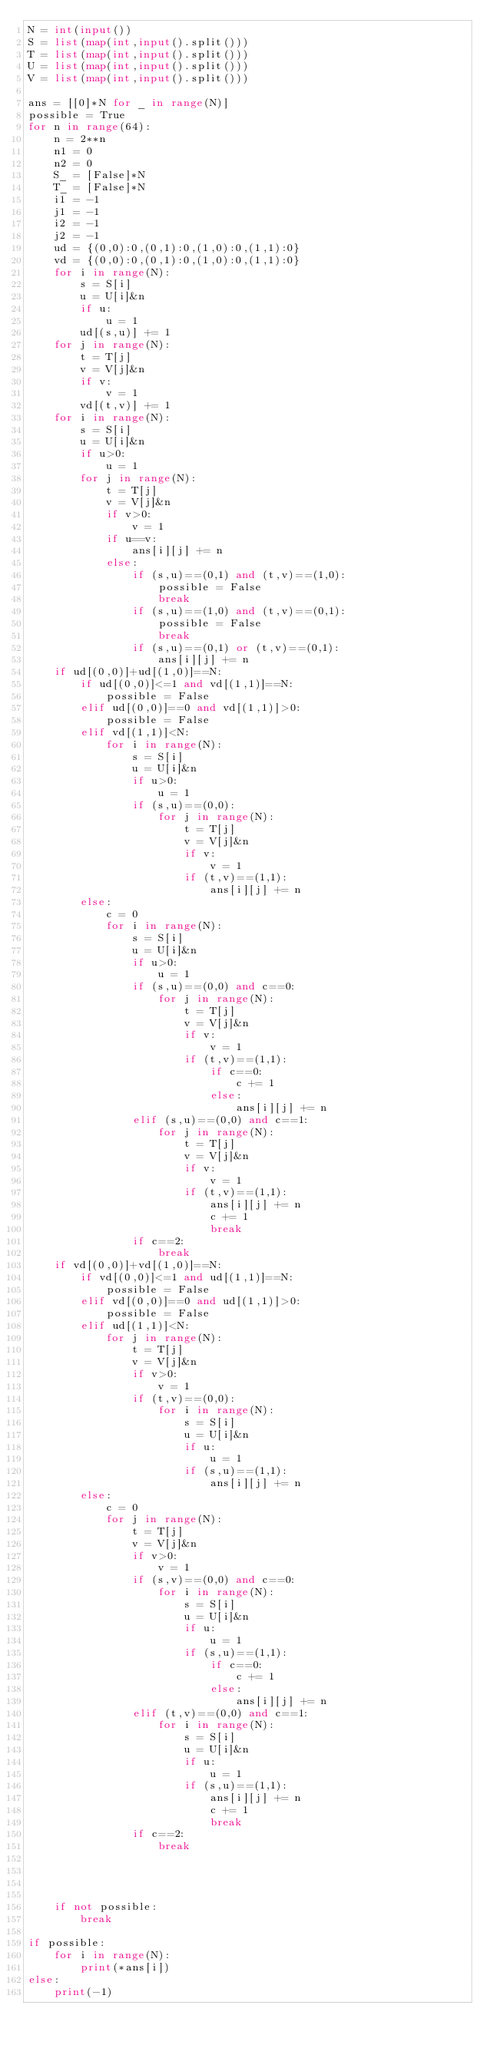Convert code to text. <code><loc_0><loc_0><loc_500><loc_500><_Python_>N = int(input())
S = list(map(int,input().split()))
T = list(map(int,input().split()))
U = list(map(int,input().split()))
V = list(map(int,input().split()))

ans = [[0]*N for _ in range(N)]
possible = True
for n in range(64):
    n = 2**n
    n1 = 0
    n2 = 0
    S_ = [False]*N
    T_ = [False]*N
    i1 = -1
    j1 = -1
    i2 = -1
    j2 = -1
    ud = {(0,0):0,(0,1):0,(1,0):0,(1,1):0}
    vd = {(0,0):0,(0,1):0,(1,0):0,(1,1):0}
    for i in range(N):
        s = S[i]
        u = U[i]&n
        if u:
            u = 1
        ud[(s,u)] += 1
    for j in range(N):
        t = T[j]
        v = V[j]&n
        if v:
            v = 1
        vd[(t,v)] += 1
    for i in range(N):
        s = S[i]
        u = U[i]&n
        if u>0:
            u = 1
        for j in range(N):
            t = T[j]
            v = V[j]&n
            if v>0:
                v = 1
            if u==v:
                ans[i][j] += n
            else:
                if (s,u)==(0,1) and (t,v)==(1,0):
                    possible = False
                    break
                if (s,u)==(1,0) and (t,v)==(0,1):
                    possible = False
                    break
                if (s,u)==(0,1) or (t,v)==(0,1):
                    ans[i][j] += n
    if ud[(0,0)]+ud[(1,0)]==N:
        if ud[(0,0)]<=1 and vd[(1,1)]==N:
            possible = False
        elif ud[(0,0)]==0 and vd[(1,1)]>0:
            possible = False
        elif vd[(1,1)]<N:
            for i in range(N):
                s = S[i]
                u = U[i]&n
                if u>0:
                    u = 1
                if (s,u)==(0,0):
                    for j in range(N):
                        t = T[j]
                        v = V[j]&n
                        if v:
                            v = 1
                        if (t,v)==(1,1):
                            ans[i][j] += n
        else:
            c = 0
            for i in range(N):
                s = S[i]
                u = U[i]&n
                if u>0:
                    u = 1
                if (s,u)==(0,0) and c==0:
                    for j in range(N):
                        t = T[j]
                        v = V[j]&n
                        if v:
                            v = 1
                        if (t,v)==(1,1):
                            if c==0:
                                c += 1
                            else:
                                ans[i][j] += n
                elif (s,u)==(0,0) and c==1:
                    for j in range(N):
                        t = T[j]
                        v = V[j]&n
                        if v:
                            v = 1
                        if (t,v)==(1,1):
                            ans[i][j] += n
                            c += 1
                            break
                if c==2:
                    break
    if vd[(0,0)]+vd[(1,0)]==N:
        if vd[(0,0)]<=1 and ud[(1,1)]==N:
            possible = False
        elif vd[(0,0)]==0 and ud[(1,1)]>0:
            possible = False
        elif ud[(1,1)]<N:
            for j in range(N):
                t = T[j]
                v = V[j]&n
                if v>0:
                    v = 1
                if (t,v)==(0,0):
                    for i in range(N):
                        s = S[i]
                        u = U[i]&n
                        if u:
                            u = 1
                        if (s,u)==(1,1):
                            ans[i][j] += n
        else:
            c = 0
            for j in range(N):
                t = T[j]
                v = V[j]&n
                if v>0:
                    v = 1
                if (s,v)==(0,0) and c==0:
                    for i in range(N):
                        s = S[i]
                        u = U[i]&n
                        if u:
                            u = 1
                        if (s,u)==(1,1):
                            if c==0:
                                c += 1
                            else:
                                ans[i][j] += n
                elif (t,v)==(0,0) and c==1:
                    for i in range(N):
                        s = S[i]
                        u = U[i]&n
                        if u:
                            u = 1
                        if (s,u)==(1,1):
                            ans[i][j] += n
                            c += 1
                            break
                if c==2:
                    break
            
                    

            
    if not possible:
        break

if possible:
    for i in range(N):
        print(*ans[i])
else:
    print(-1)</code> 